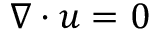Convert formula to latex. <formula><loc_0><loc_0><loc_500><loc_500>\nabla \cdot u = 0</formula> 